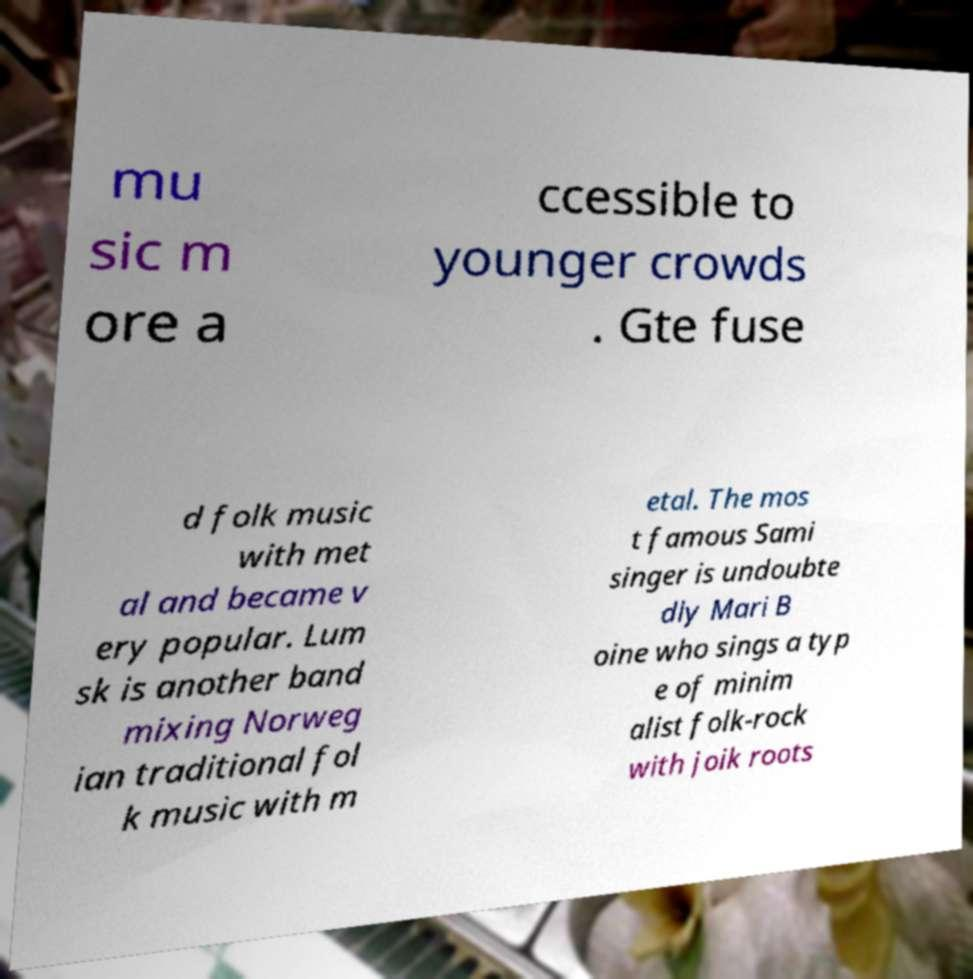Can you read and provide the text displayed in the image?This photo seems to have some interesting text. Can you extract and type it out for me? mu sic m ore a ccessible to younger crowds . Gte fuse d folk music with met al and became v ery popular. Lum sk is another band mixing Norweg ian traditional fol k music with m etal. The mos t famous Sami singer is undoubte dly Mari B oine who sings a typ e of minim alist folk-rock with joik roots 